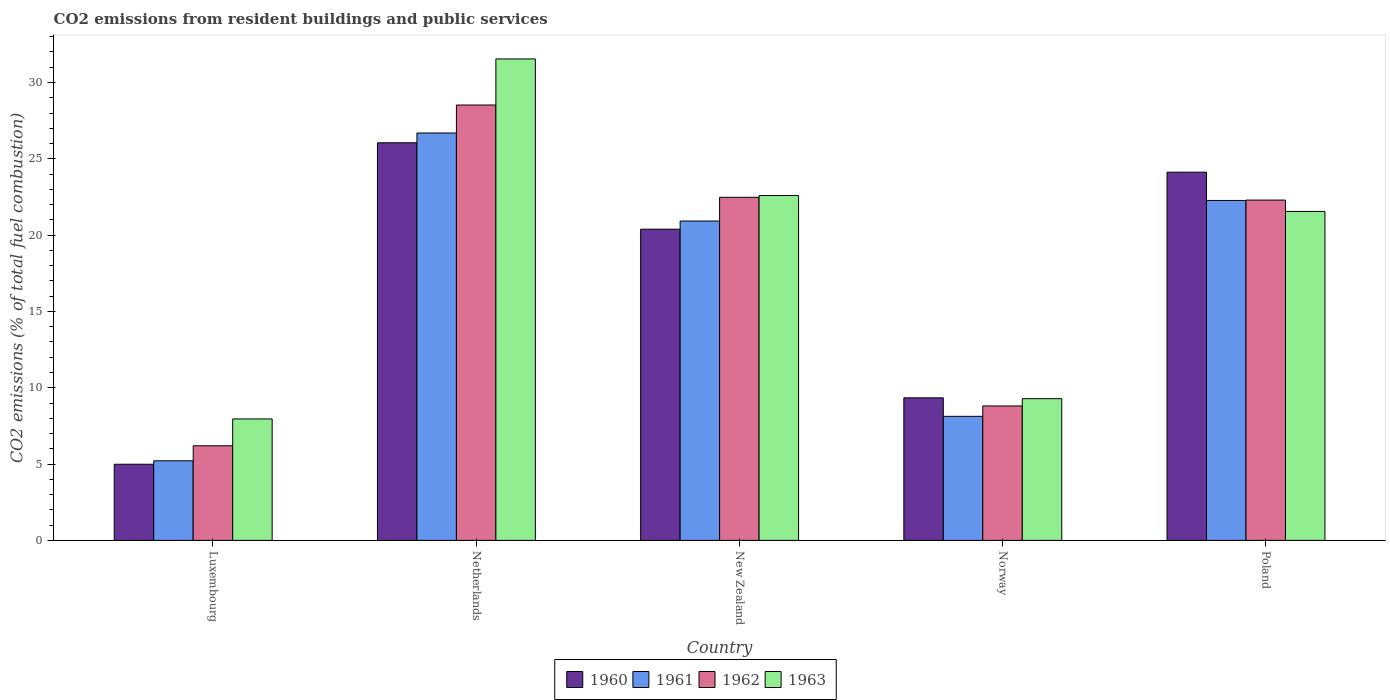How many different coloured bars are there?
Your answer should be compact. 4. How many bars are there on the 4th tick from the left?
Your answer should be compact. 4. How many bars are there on the 4th tick from the right?
Your answer should be compact. 4. What is the label of the 5th group of bars from the left?
Offer a terse response. Poland. What is the total CO2 emitted in 1963 in New Zealand?
Make the answer very short. 22.59. Across all countries, what is the maximum total CO2 emitted in 1962?
Your response must be concise. 28.52. Across all countries, what is the minimum total CO2 emitted in 1962?
Keep it short and to the point. 6.2. In which country was the total CO2 emitted in 1963 minimum?
Offer a very short reply. Luxembourg. What is the total total CO2 emitted in 1962 in the graph?
Your answer should be compact. 88.3. What is the difference between the total CO2 emitted in 1960 in Luxembourg and that in Netherlands?
Give a very brief answer. -21.06. What is the difference between the total CO2 emitted in 1962 in Netherlands and the total CO2 emitted in 1960 in Poland?
Ensure brevity in your answer.  4.4. What is the average total CO2 emitted in 1962 per country?
Offer a very short reply. 17.66. What is the difference between the total CO2 emitted of/in 1963 and total CO2 emitted of/in 1961 in New Zealand?
Your response must be concise. 1.67. What is the ratio of the total CO2 emitted in 1961 in Luxembourg to that in Norway?
Keep it short and to the point. 0.64. What is the difference between the highest and the second highest total CO2 emitted in 1963?
Keep it short and to the point. -1.04. What is the difference between the highest and the lowest total CO2 emitted in 1963?
Keep it short and to the point. 23.58. In how many countries, is the total CO2 emitted in 1960 greater than the average total CO2 emitted in 1960 taken over all countries?
Your answer should be very brief. 3. Is it the case that in every country, the sum of the total CO2 emitted in 1961 and total CO2 emitted in 1963 is greater than the sum of total CO2 emitted in 1962 and total CO2 emitted in 1960?
Offer a very short reply. No. What does the 3rd bar from the right in Luxembourg represents?
Your response must be concise. 1961. How many bars are there?
Ensure brevity in your answer.  20. Are all the bars in the graph horizontal?
Give a very brief answer. No. Are the values on the major ticks of Y-axis written in scientific E-notation?
Your response must be concise. No. How many legend labels are there?
Give a very brief answer. 4. How are the legend labels stacked?
Give a very brief answer. Horizontal. What is the title of the graph?
Make the answer very short. CO2 emissions from resident buildings and public services. Does "2008" appear as one of the legend labels in the graph?
Your answer should be very brief. No. What is the label or title of the Y-axis?
Keep it short and to the point. CO2 emissions (% of total fuel combustion). What is the CO2 emissions (% of total fuel combustion) in 1960 in Luxembourg?
Provide a short and direct response. 4.99. What is the CO2 emissions (% of total fuel combustion) of 1961 in Luxembourg?
Keep it short and to the point. 5.21. What is the CO2 emissions (% of total fuel combustion) in 1962 in Luxembourg?
Ensure brevity in your answer.  6.2. What is the CO2 emissions (% of total fuel combustion) of 1963 in Luxembourg?
Offer a terse response. 7.96. What is the CO2 emissions (% of total fuel combustion) in 1960 in Netherlands?
Provide a short and direct response. 26.05. What is the CO2 emissions (% of total fuel combustion) in 1961 in Netherlands?
Provide a short and direct response. 26.69. What is the CO2 emissions (% of total fuel combustion) in 1962 in Netherlands?
Keep it short and to the point. 28.52. What is the CO2 emissions (% of total fuel combustion) of 1963 in Netherlands?
Your answer should be very brief. 31.54. What is the CO2 emissions (% of total fuel combustion) in 1960 in New Zealand?
Keep it short and to the point. 20.39. What is the CO2 emissions (% of total fuel combustion) of 1961 in New Zealand?
Offer a terse response. 20.92. What is the CO2 emissions (% of total fuel combustion) in 1962 in New Zealand?
Your answer should be compact. 22.48. What is the CO2 emissions (% of total fuel combustion) of 1963 in New Zealand?
Keep it short and to the point. 22.59. What is the CO2 emissions (% of total fuel combustion) in 1960 in Norway?
Make the answer very short. 9.34. What is the CO2 emissions (% of total fuel combustion) in 1961 in Norway?
Your response must be concise. 8.13. What is the CO2 emissions (% of total fuel combustion) of 1962 in Norway?
Your answer should be compact. 8.81. What is the CO2 emissions (% of total fuel combustion) of 1963 in Norway?
Your answer should be compact. 9.28. What is the CO2 emissions (% of total fuel combustion) of 1960 in Poland?
Your answer should be very brief. 24.12. What is the CO2 emissions (% of total fuel combustion) in 1961 in Poland?
Make the answer very short. 22.27. What is the CO2 emissions (% of total fuel combustion) in 1962 in Poland?
Provide a short and direct response. 22.3. What is the CO2 emissions (% of total fuel combustion) in 1963 in Poland?
Give a very brief answer. 21.55. Across all countries, what is the maximum CO2 emissions (% of total fuel combustion) of 1960?
Provide a short and direct response. 26.05. Across all countries, what is the maximum CO2 emissions (% of total fuel combustion) in 1961?
Provide a short and direct response. 26.69. Across all countries, what is the maximum CO2 emissions (% of total fuel combustion) of 1962?
Make the answer very short. 28.52. Across all countries, what is the maximum CO2 emissions (% of total fuel combustion) in 1963?
Provide a succinct answer. 31.54. Across all countries, what is the minimum CO2 emissions (% of total fuel combustion) in 1960?
Make the answer very short. 4.99. Across all countries, what is the minimum CO2 emissions (% of total fuel combustion) in 1961?
Give a very brief answer. 5.21. Across all countries, what is the minimum CO2 emissions (% of total fuel combustion) of 1962?
Provide a short and direct response. 6.2. Across all countries, what is the minimum CO2 emissions (% of total fuel combustion) in 1963?
Your answer should be very brief. 7.96. What is the total CO2 emissions (% of total fuel combustion) in 1960 in the graph?
Your response must be concise. 84.89. What is the total CO2 emissions (% of total fuel combustion) in 1961 in the graph?
Provide a short and direct response. 83.23. What is the total CO2 emissions (% of total fuel combustion) of 1962 in the graph?
Provide a succinct answer. 88.3. What is the total CO2 emissions (% of total fuel combustion) in 1963 in the graph?
Give a very brief answer. 92.93. What is the difference between the CO2 emissions (% of total fuel combustion) in 1960 in Luxembourg and that in Netherlands?
Your answer should be very brief. -21.06. What is the difference between the CO2 emissions (% of total fuel combustion) of 1961 in Luxembourg and that in Netherlands?
Your response must be concise. -21.48. What is the difference between the CO2 emissions (% of total fuel combustion) in 1962 in Luxembourg and that in Netherlands?
Make the answer very short. -22.33. What is the difference between the CO2 emissions (% of total fuel combustion) of 1963 in Luxembourg and that in Netherlands?
Provide a short and direct response. -23.58. What is the difference between the CO2 emissions (% of total fuel combustion) in 1960 in Luxembourg and that in New Zealand?
Keep it short and to the point. -15.4. What is the difference between the CO2 emissions (% of total fuel combustion) in 1961 in Luxembourg and that in New Zealand?
Make the answer very short. -15.71. What is the difference between the CO2 emissions (% of total fuel combustion) in 1962 in Luxembourg and that in New Zealand?
Offer a very short reply. -16.28. What is the difference between the CO2 emissions (% of total fuel combustion) in 1963 in Luxembourg and that in New Zealand?
Provide a short and direct response. -14.63. What is the difference between the CO2 emissions (% of total fuel combustion) of 1960 in Luxembourg and that in Norway?
Your answer should be very brief. -4.35. What is the difference between the CO2 emissions (% of total fuel combustion) of 1961 in Luxembourg and that in Norway?
Provide a short and direct response. -2.91. What is the difference between the CO2 emissions (% of total fuel combustion) in 1962 in Luxembourg and that in Norway?
Provide a succinct answer. -2.61. What is the difference between the CO2 emissions (% of total fuel combustion) of 1963 in Luxembourg and that in Norway?
Make the answer very short. -1.33. What is the difference between the CO2 emissions (% of total fuel combustion) of 1960 in Luxembourg and that in Poland?
Offer a very short reply. -19.13. What is the difference between the CO2 emissions (% of total fuel combustion) of 1961 in Luxembourg and that in Poland?
Keep it short and to the point. -17.06. What is the difference between the CO2 emissions (% of total fuel combustion) of 1962 in Luxembourg and that in Poland?
Your answer should be very brief. -16.1. What is the difference between the CO2 emissions (% of total fuel combustion) in 1963 in Luxembourg and that in Poland?
Your response must be concise. -13.59. What is the difference between the CO2 emissions (% of total fuel combustion) of 1960 in Netherlands and that in New Zealand?
Provide a short and direct response. 5.66. What is the difference between the CO2 emissions (% of total fuel combustion) in 1961 in Netherlands and that in New Zealand?
Give a very brief answer. 5.77. What is the difference between the CO2 emissions (% of total fuel combustion) of 1962 in Netherlands and that in New Zealand?
Provide a succinct answer. 6.05. What is the difference between the CO2 emissions (% of total fuel combustion) of 1963 in Netherlands and that in New Zealand?
Provide a succinct answer. 8.95. What is the difference between the CO2 emissions (% of total fuel combustion) in 1960 in Netherlands and that in Norway?
Your answer should be compact. 16.71. What is the difference between the CO2 emissions (% of total fuel combustion) in 1961 in Netherlands and that in Norway?
Offer a very short reply. 18.56. What is the difference between the CO2 emissions (% of total fuel combustion) in 1962 in Netherlands and that in Norway?
Offer a terse response. 19.72. What is the difference between the CO2 emissions (% of total fuel combustion) of 1963 in Netherlands and that in Norway?
Keep it short and to the point. 22.26. What is the difference between the CO2 emissions (% of total fuel combustion) in 1960 in Netherlands and that in Poland?
Your answer should be very brief. 1.93. What is the difference between the CO2 emissions (% of total fuel combustion) of 1961 in Netherlands and that in Poland?
Provide a succinct answer. 4.42. What is the difference between the CO2 emissions (% of total fuel combustion) in 1962 in Netherlands and that in Poland?
Your response must be concise. 6.23. What is the difference between the CO2 emissions (% of total fuel combustion) in 1963 in Netherlands and that in Poland?
Make the answer very short. 9.99. What is the difference between the CO2 emissions (% of total fuel combustion) of 1960 in New Zealand and that in Norway?
Your answer should be compact. 11.05. What is the difference between the CO2 emissions (% of total fuel combustion) of 1961 in New Zealand and that in Norway?
Provide a succinct answer. 12.8. What is the difference between the CO2 emissions (% of total fuel combustion) of 1962 in New Zealand and that in Norway?
Give a very brief answer. 13.67. What is the difference between the CO2 emissions (% of total fuel combustion) of 1963 in New Zealand and that in Norway?
Your answer should be compact. 13.31. What is the difference between the CO2 emissions (% of total fuel combustion) in 1960 in New Zealand and that in Poland?
Offer a very short reply. -3.73. What is the difference between the CO2 emissions (% of total fuel combustion) of 1961 in New Zealand and that in Poland?
Offer a very short reply. -1.35. What is the difference between the CO2 emissions (% of total fuel combustion) of 1962 in New Zealand and that in Poland?
Offer a terse response. 0.18. What is the difference between the CO2 emissions (% of total fuel combustion) in 1963 in New Zealand and that in Poland?
Keep it short and to the point. 1.04. What is the difference between the CO2 emissions (% of total fuel combustion) in 1960 in Norway and that in Poland?
Your answer should be very brief. -14.78. What is the difference between the CO2 emissions (% of total fuel combustion) in 1961 in Norway and that in Poland?
Your answer should be compact. -14.14. What is the difference between the CO2 emissions (% of total fuel combustion) of 1962 in Norway and that in Poland?
Provide a short and direct response. -13.49. What is the difference between the CO2 emissions (% of total fuel combustion) in 1963 in Norway and that in Poland?
Your answer should be very brief. -12.27. What is the difference between the CO2 emissions (% of total fuel combustion) of 1960 in Luxembourg and the CO2 emissions (% of total fuel combustion) of 1961 in Netherlands?
Your answer should be very brief. -21.7. What is the difference between the CO2 emissions (% of total fuel combustion) of 1960 in Luxembourg and the CO2 emissions (% of total fuel combustion) of 1962 in Netherlands?
Provide a succinct answer. -23.54. What is the difference between the CO2 emissions (% of total fuel combustion) of 1960 in Luxembourg and the CO2 emissions (% of total fuel combustion) of 1963 in Netherlands?
Give a very brief answer. -26.55. What is the difference between the CO2 emissions (% of total fuel combustion) of 1961 in Luxembourg and the CO2 emissions (% of total fuel combustion) of 1962 in Netherlands?
Your response must be concise. -23.31. What is the difference between the CO2 emissions (% of total fuel combustion) in 1961 in Luxembourg and the CO2 emissions (% of total fuel combustion) in 1963 in Netherlands?
Offer a very short reply. -26.33. What is the difference between the CO2 emissions (% of total fuel combustion) in 1962 in Luxembourg and the CO2 emissions (% of total fuel combustion) in 1963 in Netherlands?
Make the answer very short. -25.34. What is the difference between the CO2 emissions (% of total fuel combustion) of 1960 in Luxembourg and the CO2 emissions (% of total fuel combustion) of 1961 in New Zealand?
Ensure brevity in your answer.  -15.94. What is the difference between the CO2 emissions (% of total fuel combustion) in 1960 in Luxembourg and the CO2 emissions (% of total fuel combustion) in 1962 in New Zealand?
Your answer should be very brief. -17.49. What is the difference between the CO2 emissions (% of total fuel combustion) in 1960 in Luxembourg and the CO2 emissions (% of total fuel combustion) in 1963 in New Zealand?
Give a very brief answer. -17.6. What is the difference between the CO2 emissions (% of total fuel combustion) of 1961 in Luxembourg and the CO2 emissions (% of total fuel combustion) of 1962 in New Zealand?
Your answer should be compact. -17.26. What is the difference between the CO2 emissions (% of total fuel combustion) of 1961 in Luxembourg and the CO2 emissions (% of total fuel combustion) of 1963 in New Zealand?
Provide a succinct answer. -17.38. What is the difference between the CO2 emissions (% of total fuel combustion) in 1962 in Luxembourg and the CO2 emissions (% of total fuel combustion) in 1963 in New Zealand?
Your response must be concise. -16.39. What is the difference between the CO2 emissions (% of total fuel combustion) in 1960 in Luxembourg and the CO2 emissions (% of total fuel combustion) in 1961 in Norway?
Your answer should be compact. -3.14. What is the difference between the CO2 emissions (% of total fuel combustion) in 1960 in Luxembourg and the CO2 emissions (% of total fuel combustion) in 1962 in Norway?
Offer a terse response. -3.82. What is the difference between the CO2 emissions (% of total fuel combustion) in 1960 in Luxembourg and the CO2 emissions (% of total fuel combustion) in 1963 in Norway?
Your answer should be very brief. -4.3. What is the difference between the CO2 emissions (% of total fuel combustion) of 1961 in Luxembourg and the CO2 emissions (% of total fuel combustion) of 1962 in Norway?
Make the answer very short. -3.59. What is the difference between the CO2 emissions (% of total fuel combustion) of 1961 in Luxembourg and the CO2 emissions (% of total fuel combustion) of 1963 in Norway?
Provide a short and direct response. -4.07. What is the difference between the CO2 emissions (% of total fuel combustion) of 1962 in Luxembourg and the CO2 emissions (% of total fuel combustion) of 1963 in Norway?
Your response must be concise. -3.09. What is the difference between the CO2 emissions (% of total fuel combustion) in 1960 in Luxembourg and the CO2 emissions (% of total fuel combustion) in 1961 in Poland?
Provide a succinct answer. -17.28. What is the difference between the CO2 emissions (% of total fuel combustion) of 1960 in Luxembourg and the CO2 emissions (% of total fuel combustion) of 1962 in Poland?
Your answer should be compact. -17.31. What is the difference between the CO2 emissions (% of total fuel combustion) of 1960 in Luxembourg and the CO2 emissions (% of total fuel combustion) of 1963 in Poland?
Ensure brevity in your answer.  -16.56. What is the difference between the CO2 emissions (% of total fuel combustion) of 1961 in Luxembourg and the CO2 emissions (% of total fuel combustion) of 1962 in Poland?
Ensure brevity in your answer.  -17.08. What is the difference between the CO2 emissions (% of total fuel combustion) in 1961 in Luxembourg and the CO2 emissions (% of total fuel combustion) in 1963 in Poland?
Your response must be concise. -16.34. What is the difference between the CO2 emissions (% of total fuel combustion) in 1962 in Luxembourg and the CO2 emissions (% of total fuel combustion) in 1963 in Poland?
Your response must be concise. -15.35. What is the difference between the CO2 emissions (% of total fuel combustion) of 1960 in Netherlands and the CO2 emissions (% of total fuel combustion) of 1961 in New Zealand?
Offer a very short reply. 5.13. What is the difference between the CO2 emissions (% of total fuel combustion) of 1960 in Netherlands and the CO2 emissions (% of total fuel combustion) of 1962 in New Zealand?
Your answer should be very brief. 3.57. What is the difference between the CO2 emissions (% of total fuel combustion) in 1960 in Netherlands and the CO2 emissions (% of total fuel combustion) in 1963 in New Zealand?
Make the answer very short. 3.46. What is the difference between the CO2 emissions (% of total fuel combustion) in 1961 in Netherlands and the CO2 emissions (% of total fuel combustion) in 1962 in New Zealand?
Keep it short and to the point. 4.21. What is the difference between the CO2 emissions (% of total fuel combustion) in 1961 in Netherlands and the CO2 emissions (% of total fuel combustion) in 1963 in New Zealand?
Make the answer very short. 4.1. What is the difference between the CO2 emissions (% of total fuel combustion) in 1962 in Netherlands and the CO2 emissions (% of total fuel combustion) in 1963 in New Zealand?
Ensure brevity in your answer.  5.93. What is the difference between the CO2 emissions (% of total fuel combustion) of 1960 in Netherlands and the CO2 emissions (% of total fuel combustion) of 1961 in Norway?
Provide a succinct answer. 17.92. What is the difference between the CO2 emissions (% of total fuel combustion) in 1960 in Netherlands and the CO2 emissions (% of total fuel combustion) in 1962 in Norway?
Your answer should be compact. 17.24. What is the difference between the CO2 emissions (% of total fuel combustion) in 1960 in Netherlands and the CO2 emissions (% of total fuel combustion) in 1963 in Norway?
Your answer should be compact. 16.76. What is the difference between the CO2 emissions (% of total fuel combustion) in 1961 in Netherlands and the CO2 emissions (% of total fuel combustion) in 1962 in Norway?
Your response must be concise. 17.88. What is the difference between the CO2 emissions (% of total fuel combustion) of 1961 in Netherlands and the CO2 emissions (% of total fuel combustion) of 1963 in Norway?
Your answer should be very brief. 17.41. What is the difference between the CO2 emissions (% of total fuel combustion) in 1962 in Netherlands and the CO2 emissions (% of total fuel combustion) in 1963 in Norway?
Make the answer very short. 19.24. What is the difference between the CO2 emissions (% of total fuel combustion) in 1960 in Netherlands and the CO2 emissions (% of total fuel combustion) in 1961 in Poland?
Ensure brevity in your answer.  3.78. What is the difference between the CO2 emissions (% of total fuel combustion) in 1960 in Netherlands and the CO2 emissions (% of total fuel combustion) in 1962 in Poland?
Your answer should be compact. 3.75. What is the difference between the CO2 emissions (% of total fuel combustion) of 1960 in Netherlands and the CO2 emissions (% of total fuel combustion) of 1963 in Poland?
Give a very brief answer. 4.5. What is the difference between the CO2 emissions (% of total fuel combustion) in 1961 in Netherlands and the CO2 emissions (% of total fuel combustion) in 1962 in Poland?
Offer a terse response. 4.4. What is the difference between the CO2 emissions (% of total fuel combustion) in 1961 in Netherlands and the CO2 emissions (% of total fuel combustion) in 1963 in Poland?
Offer a very short reply. 5.14. What is the difference between the CO2 emissions (% of total fuel combustion) in 1962 in Netherlands and the CO2 emissions (% of total fuel combustion) in 1963 in Poland?
Keep it short and to the point. 6.97. What is the difference between the CO2 emissions (% of total fuel combustion) of 1960 in New Zealand and the CO2 emissions (% of total fuel combustion) of 1961 in Norway?
Your response must be concise. 12.26. What is the difference between the CO2 emissions (% of total fuel combustion) in 1960 in New Zealand and the CO2 emissions (% of total fuel combustion) in 1962 in Norway?
Give a very brief answer. 11.58. What is the difference between the CO2 emissions (% of total fuel combustion) of 1960 in New Zealand and the CO2 emissions (% of total fuel combustion) of 1963 in Norway?
Make the answer very short. 11.1. What is the difference between the CO2 emissions (% of total fuel combustion) in 1961 in New Zealand and the CO2 emissions (% of total fuel combustion) in 1962 in Norway?
Provide a short and direct response. 12.12. What is the difference between the CO2 emissions (% of total fuel combustion) in 1961 in New Zealand and the CO2 emissions (% of total fuel combustion) in 1963 in Norway?
Offer a terse response. 11.64. What is the difference between the CO2 emissions (% of total fuel combustion) in 1962 in New Zealand and the CO2 emissions (% of total fuel combustion) in 1963 in Norway?
Provide a short and direct response. 13.19. What is the difference between the CO2 emissions (% of total fuel combustion) in 1960 in New Zealand and the CO2 emissions (% of total fuel combustion) in 1961 in Poland?
Your response must be concise. -1.88. What is the difference between the CO2 emissions (% of total fuel combustion) of 1960 in New Zealand and the CO2 emissions (% of total fuel combustion) of 1962 in Poland?
Your answer should be very brief. -1.91. What is the difference between the CO2 emissions (% of total fuel combustion) in 1960 in New Zealand and the CO2 emissions (% of total fuel combustion) in 1963 in Poland?
Provide a short and direct response. -1.16. What is the difference between the CO2 emissions (% of total fuel combustion) in 1961 in New Zealand and the CO2 emissions (% of total fuel combustion) in 1962 in Poland?
Your response must be concise. -1.37. What is the difference between the CO2 emissions (% of total fuel combustion) of 1961 in New Zealand and the CO2 emissions (% of total fuel combustion) of 1963 in Poland?
Provide a succinct answer. -0.63. What is the difference between the CO2 emissions (% of total fuel combustion) of 1962 in New Zealand and the CO2 emissions (% of total fuel combustion) of 1963 in Poland?
Your response must be concise. 0.93. What is the difference between the CO2 emissions (% of total fuel combustion) of 1960 in Norway and the CO2 emissions (% of total fuel combustion) of 1961 in Poland?
Provide a short and direct response. -12.93. What is the difference between the CO2 emissions (% of total fuel combustion) of 1960 in Norway and the CO2 emissions (% of total fuel combustion) of 1962 in Poland?
Provide a succinct answer. -12.96. What is the difference between the CO2 emissions (% of total fuel combustion) in 1960 in Norway and the CO2 emissions (% of total fuel combustion) in 1963 in Poland?
Offer a very short reply. -12.21. What is the difference between the CO2 emissions (% of total fuel combustion) in 1961 in Norway and the CO2 emissions (% of total fuel combustion) in 1962 in Poland?
Ensure brevity in your answer.  -14.17. What is the difference between the CO2 emissions (% of total fuel combustion) in 1961 in Norway and the CO2 emissions (% of total fuel combustion) in 1963 in Poland?
Make the answer very short. -13.42. What is the difference between the CO2 emissions (% of total fuel combustion) in 1962 in Norway and the CO2 emissions (% of total fuel combustion) in 1963 in Poland?
Your response must be concise. -12.74. What is the average CO2 emissions (% of total fuel combustion) in 1960 per country?
Offer a terse response. 16.98. What is the average CO2 emissions (% of total fuel combustion) in 1961 per country?
Your answer should be very brief. 16.65. What is the average CO2 emissions (% of total fuel combustion) of 1962 per country?
Offer a terse response. 17.66. What is the average CO2 emissions (% of total fuel combustion) in 1963 per country?
Your answer should be compact. 18.59. What is the difference between the CO2 emissions (% of total fuel combustion) of 1960 and CO2 emissions (% of total fuel combustion) of 1961 in Luxembourg?
Keep it short and to the point. -0.23. What is the difference between the CO2 emissions (% of total fuel combustion) of 1960 and CO2 emissions (% of total fuel combustion) of 1962 in Luxembourg?
Give a very brief answer. -1.21. What is the difference between the CO2 emissions (% of total fuel combustion) of 1960 and CO2 emissions (% of total fuel combustion) of 1963 in Luxembourg?
Give a very brief answer. -2.97. What is the difference between the CO2 emissions (% of total fuel combustion) in 1961 and CO2 emissions (% of total fuel combustion) in 1962 in Luxembourg?
Give a very brief answer. -0.98. What is the difference between the CO2 emissions (% of total fuel combustion) of 1961 and CO2 emissions (% of total fuel combustion) of 1963 in Luxembourg?
Your response must be concise. -2.74. What is the difference between the CO2 emissions (% of total fuel combustion) in 1962 and CO2 emissions (% of total fuel combustion) in 1963 in Luxembourg?
Your answer should be compact. -1.76. What is the difference between the CO2 emissions (% of total fuel combustion) of 1960 and CO2 emissions (% of total fuel combustion) of 1961 in Netherlands?
Offer a very short reply. -0.64. What is the difference between the CO2 emissions (% of total fuel combustion) of 1960 and CO2 emissions (% of total fuel combustion) of 1962 in Netherlands?
Your answer should be compact. -2.47. What is the difference between the CO2 emissions (% of total fuel combustion) in 1960 and CO2 emissions (% of total fuel combustion) in 1963 in Netherlands?
Keep it short and to the point. -5.49. What is the difference between the CO2 emissions (% of total fuel combustion) in 1961 and CO2 emissions (% of total fuel combustion) in 1962 in Netherlands?
Keep it short and to the point. -1.83. What is the difference between the CO2 emissions (% of total fuel combustion) in 1961 and CO2 emissions (% of total fuel combustion) in 1963 in Netherlands?
Keep it short and to the point. -4.85. What is the difference between the CO2 emissions (% of total fuel combustion) of 1962 and CO2 emissions (% of total fuel combustion) of 1963 in Netherlands?
Make the answer very short. -3.02. What is the difference between the CO2 emissions (% of total fuel combustion) in 1960 and CO2 emissions (% of total fuel combustion) in 1961 in New Zealand?
Provide a short and direct response. -0.54. What is the difference between the CO2 emissions (% of total fuel combustion) of 1960 and CO2 emissions (% of total fuel combustion) of 1962 in New Zealand?
Offer a terse response. -2.09. What is the difference between the CO2 emissions (% of total fuel combustion) of 1960 and CO2 emissions (% of total fuel combustion) of 1963 in New Zealand?
Ensure brevity in your answer.  -2.2. What is the difference between the CO2 emissions (% of total fuel combustion) in 1961 and CO2 emissions (% of total fuel combustion) in 1962 in New Zealand?
Ensure brevity in your answer.  -1.55. What is the difference between the CO2 emissions (% of total fuel combustion) of 1961 and CO2 emissions (% of total fuel combustion) of 1963 in New Zealand?
Provide a short and direct response. -1.67. What is the difference between the CO2 emissions (% of total fuel combustion) of 1962 and CO2 emissions (% of total fuel combustion) of 1963 in New Zealand?
Make the answer very short. -0.12. What is the difference between the CO2 emissions (% of total fuel combustion) of 1960 and CO2 emissions (% of total fuel combustion) of 1961 in Norway?
Provide a short and direct response. 1.21. What is the difference between the CO2 emissions (% of total fuel combustion) in 1960 and CO2 emissions (% of total fuel combustion) in 1962 in Norway?
Keep it short and to the point. 0.53. What is the difference between the CO2 emissions (% of total fuel combustion) of 1960 and CO2 emissions (% of total fuel combustion) of 1963 in Norway?
Provide a succinct answer. 0.05. What is the difference between the CO2 emissions (% of total fuel combustion) in 1961 and CO2 emissions (% of total fuel combustion) in 1962 in Norway?
Provide a succinct answer. -0.68. What is the difference between the CO2 emissions (% of total fuel combustion) of 1961 and CO2 emissions (% of total fuel combustion) of 1963 in Norway?
Make the answer very short. -1.16. What is the difference between the CO2 emissions (% of total fuel combustion) of 1962 and CO2 emissions (% of total fuel combustion) of 1963 in Norway?
Your answer should be very brief. -0.48. What is the difference between the CO2 emissions (% of total fuel combustion) of 1960 and CO2 emissions (% of total fuel combustion) of 1961 in Poland?
Offer a terse response. 1.85. What is the difference between the CO2 emissions (% of total fuel combustion) of 1960 and CO2 emissions (% of total fuel combustion) of 1962 in Poland?
Provide a short and direct response. 1.83. What is the difference between the CO2 emissions (% of total fuel combustion) of 1960 and CO2 emissions (% of total fuel combustion) of 1963 in Poland?
Provide a succinct answer. 2.57. What is the difference between the CO2 emissions (% of total fuel combustion) of 1961 and CO2 emissions (% of total fuel combustion) of 1962 in Poland?
Provide a short and direct response. -0.02. What is the difference between the CO2 emissions (% of total fuel combustion) of 1961 and CO2 emissions (% of total fuel combustion) of 1963 in Poland?
Your answer should be very brief. 0.72. What is the difference between the CO2 emissions (% of total fuel combustion) of 1962 and CO2 emissions (% of total fuel combustion) of 1963 in Poland?
Keep it short and to the point. 0.74. What is the ratio of the CO2 emissions (% of total fuel combustion) of 1960 in Luxembourg to that in Netherlands?
Make the answer very short. 0.19. What is the ratio of the CO2 emissions (% of total fuel combustion) in 1961 in Luxembourg to that in Netherlands?
Ensure brevity in your answer.  0.2. What is the ratio of the CO2 emissions (% of total fuel combustion) of 1962 in Luxembourg to that in Netherlands?
Offer a terse response. 0.22. What is the ratio of the CO2 emissions (% of total fuel combustion) of 1963 in Luxembourg to that in Netherlands?
Offer a very short reply. 0.25. What is the ratio of the CO2 emissions (% of total fuel combustion) in 1960 in Luxembourg to that in New Zealand?
Your answer should be very brief. 0.24. What is the ratio of the CO2 emissions (% of total fuel combustion) of 1961 in Luxembourg to that in New Zealand?
Give a very brief answer. 0.25. What is the ratio of the CO2 emissions (% of total fuel combustion) in 1962 in Luxembourg to that in New Zealand?
Your answer should be very brief. 0.28. What is the ratio of the CO2 emissions (% of total fuel combustion) in 1963 in Luxembourg to that in New Zealand?
Your response must be concise. 0.35. What is the ratio of the CO2 emissions (% of total fuel combustion) in 1960 in Luxembourg to that in Norway?
Offer a very short reply. 0.53. What is the ratio of the CO2 emissions (% of total fuel combustion) in 1961 in Luxembourg to that in Norway?
Your answer should be very brief. 0.64. What is the ratio of the CO2 emissions (% of total fuel combustion) in 1962 in Luxembourg to that in Norway?
Offer a very short reply. 0.7. What is the ratio of the CO2 emissions (% of total fuel combustion) in 1960 in Luxembourg to that in Poland?
Your answer should be very brief. 0.21. What is the ratio of the CO2 emissions (% of total fuel combustion) in 1961 in Luxembourg to that in Poland?
Offer a terse response. 0.23. What is the ratio of the CO2 emissions (% of total fuel combustion) in 1962 in Luxembourg to that in Poland?
Your answer should be compact. 0.28. What is the ratio of the CO2 emissions (% of total fuel combustion) in 1963 in Luxembourg to that in Poland?
Provide a succinct answer. 0.37. What is the ratio of the CO2 emissions (% of total fuel combustion) of 1960 in Netherlands to that in New Zealand?
Provide a succinct answer. 1.28. What is the ratio of the CO2 emissions (% of total fuel combustion) of 1961 in Netherlands to that in New Zealand?
Your response must be concise. 1.28. What is the ratio of the CO2 emissions (% of total fuel combustion) in 1962 in Netherlands to that in New Zealand?
Give a very brief answer. 1.27. What is the ratio of the CO2 emissions (% of total fuel combustion) in 1963 in Netherlands to that in New Zealand?
Make the answer very short. 1.4. What is the ratio of the CO2 emissions (% of total fuel combustion) in 1960 in Netherlands to that in Norway?
Ensure brevity in your answer.  2.79. What is the ratio of the CO2 emissions (% of total fuel combustion) of 1961 in Netherlands to that in Norway?
Your response must be concise. 3.28. What is the ratio of the CO2 emissions (% of total fuel combustion) of 1962 in Netherlands to that in Norway?
Offer a very short reply. 3.24. What is the ratio of the CO2 emissions (% of total fuel combustion) of 1963 in Netherlands to that in Norway?
Your response must be concise. 3.4. What is the ratio of the CO2 emissions (% of total fuel combustion) of 1960 in Netherlands to that in Poland?
Give a very brief answer. 1.08. What is the ratio of the CO2 emissions (% of total fuel combustion) of 1961 in Netherlands to that in Poland?
Provide a short and direct response. 1.2. What is the ratio of the CO2 emissions (% of total fuel combustion) in 1962 in Netherlands to that in Poland?
Ensure brevity in your answer.  1.28. What is the ratio of the CO2 emissions (% of total fuel combustion) in 1963 in Netherlands to that in Poland?
Your answer should be very brief. 1.46. What is the ratio of the CO2 emissions (% of total fuel combustion) in 1960 in New Zealand to that in Norway?
Keep it short and to the point. 2.18. What is the ratio of the CO2 emissions (% of total fuel combustion) of 1961 in New Zealand to that in Norway?
Give a very brief answer. 2.57. What is the ratio of the CO2 emissions (% of total fuel combustion) in 1962 in New Zealand to that in Norway?
Give a very brief answer. 2.55. What is the ratio of the CO2 emissions (% of total fuel combustion) of 1963 in New Zealand to that in Norway?
Ensure brevity in your answer.  2.43. What is the ratio of the CO2 emissions (% of total fuel combustion) of 1960 in New Zealand to that in Poland?
Ensure brevity in your answer.  0.85. What is the ratio of the CO2 emissions (% of total fuel combustion) in 1961 in New Zealand to that in Poland?
Provide a succinct answer. 0.94. What is the ratio of the CO2 emissions (% of total fuel combustion) in 1962 in New Zealand to that in Poland?
Give a very brief answer. 1.01. What is the ratio of the CO2 emissions (% of total fuel combustion) of 1963 in New Zealand to that in Poland?
Make the answer very short. 1.05. What is the ratio of the CO2 emissions (% of total fuel combustion) of 1960 in Norway to that in Poland?
Provide a succinct answer. 0.39. What is the ratio of the CO2 emissions (% of total fuel combustion) in 1961 in Norway to that in Poland?
Your answer should be very brief. 0.36. What is the ratio of the CO2 emissions (% of total fuel combustion) of 1962 in Norway to that in Poland?
Provide a succinct answer. 0.4. What is the ratio of the CO2 emissions (% of total fuel combustion) in 1963 in Norway to that in Poland?
Your answer should be very brief. 0.43. What is the difference between the highest and the second highest CO2 emissions (% of total fuel combustion) in 1960?
Keep it short and to the point. 1.93. What is the difference between the highest and the second highest CO2 emissions (% of total fuel combustion) of 1961?
Your answer should be compact. 4.42. What is the difference between the highest and the second highest CO2 emissions (% of total fuel combustion) in 1962?
Give a very brief answer. 6.05. What is the difference between the highest and the second highest CO2 emissions (% of total fuel combustion) in 1963?
Offer a very short reply. 8.95. What is the difference between the highest and the lowest CO2 emissions (% of total fuel combustion) in 1960?
Ensure brevity in your answer.  21.06. What is the difference between the highest and the lowest CO2 emissions (% of total fuel combustion) of 1961?
Offer a terse response. 21.48. What is the difference between the highest and the lowest CO2 emissions (% of total fuel combustion) of 1962?
Offer a very short reply. 22.33. What is the difference between the highest and the lowest CO2 emissions (% of total fuel combustion) in 1963?
Your response must be concise. 23.58. 